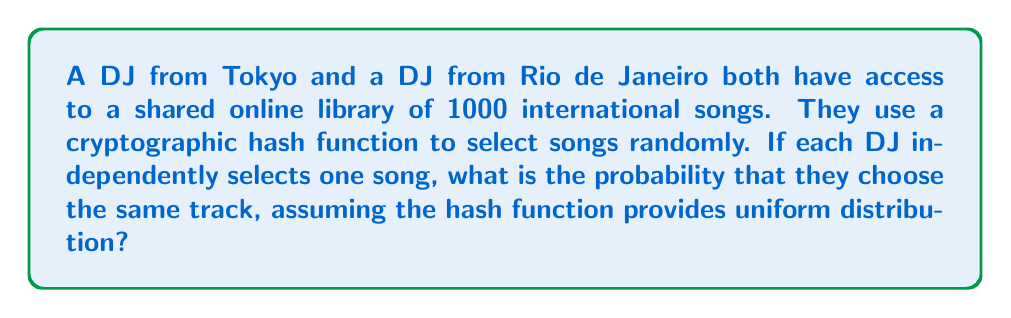Could you help me with this problem? Let's approach this step-by-step using principles from cryptography and probability theory:

1) In cryptography, a good hash function should provide uniform distribution over its output range. This means each song in the library has an equal probability of being selected.

2) The probability of the first DJ selecting any particular song is:

   $P(\text{DJ1 selects a song}) = \frac{1}{1000}$

3) For the second DJ to select the same song, we need to calculate the probability of this specific event occurring. Given that the selections are independent, this probability is also:

   $P(\text{DJ2 selects the same song}) = \frac{1}{1000}$

4) To find the probability of both events occurring together (i.e., both DJs selecting the same song), we multiply these probabilities:

   $P(\text{Both select same song}) = P(\text{DJ1 selects a song}) \times P(\text{DJ2 selects the same song})$

   $= \frac{1}{1000} \times \frac{1}{1000} = \frac{1}{1,000,000} = 0.000001$

5) This can also be expressed as:

   $P(\text{Both select same song}) = \frac{1}{N}$

   Where $N$ is the total number of songs in the library.

This result aligns with the "Birthday Paradox" principle in cryptography, which is often used to analyze collision resistance in hash functions.
Answer: $\frac{1}{1000000}$ or $0.000001$ or $1 \times 10^{-6}$ 